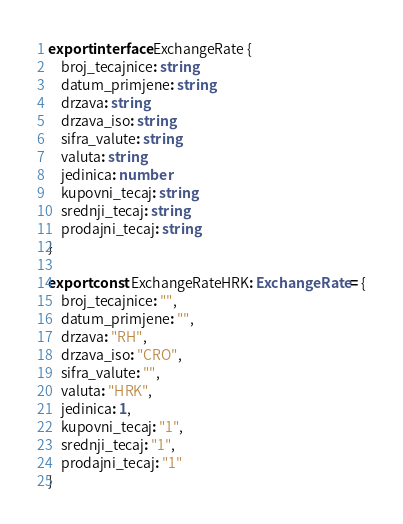Convert code to text. <code><loc_0><loc_0><loc_500><loc_500><_TypeScript_>export interface ExchangeRate {
    broj_tecajnice: string
    datum_primjene: string
    drzava: string
    drzava_iso: string
    sifra_valute: string
    valuta: string
    jedinica: number
    kupovni_tecaj: string
    srednji_tecaj: string
    prodajni_tecaj: string
}

export const ExchangeRateHRK: ExchangeRate = {
    broj_tecajnice: "",
    datum_primjene: "",
    drzava: "RH",
    drzava_iso: "CRO",
    sifra_valute: "",
    valuta: "HRK",
    jedinica: 1,
    kupovni_tecaj: "1",
    srednji_tecaj: "1",
    prodajni_tecaj: "1"
}</code> 